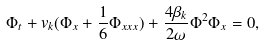Convert formula to latex. <formula><loc_0><loc_0><loc_500><loc_500>\Phi _ { t } + v _ { k } ( \Phi _ { x } + \frac { 1 } { 6 } \Phi _ { x x x } ) + \frac { 4 \beta _ { k } } { 2 \omega } \Phi ^ { 2 } \Phi _ { x } = 0 ,</formula> 